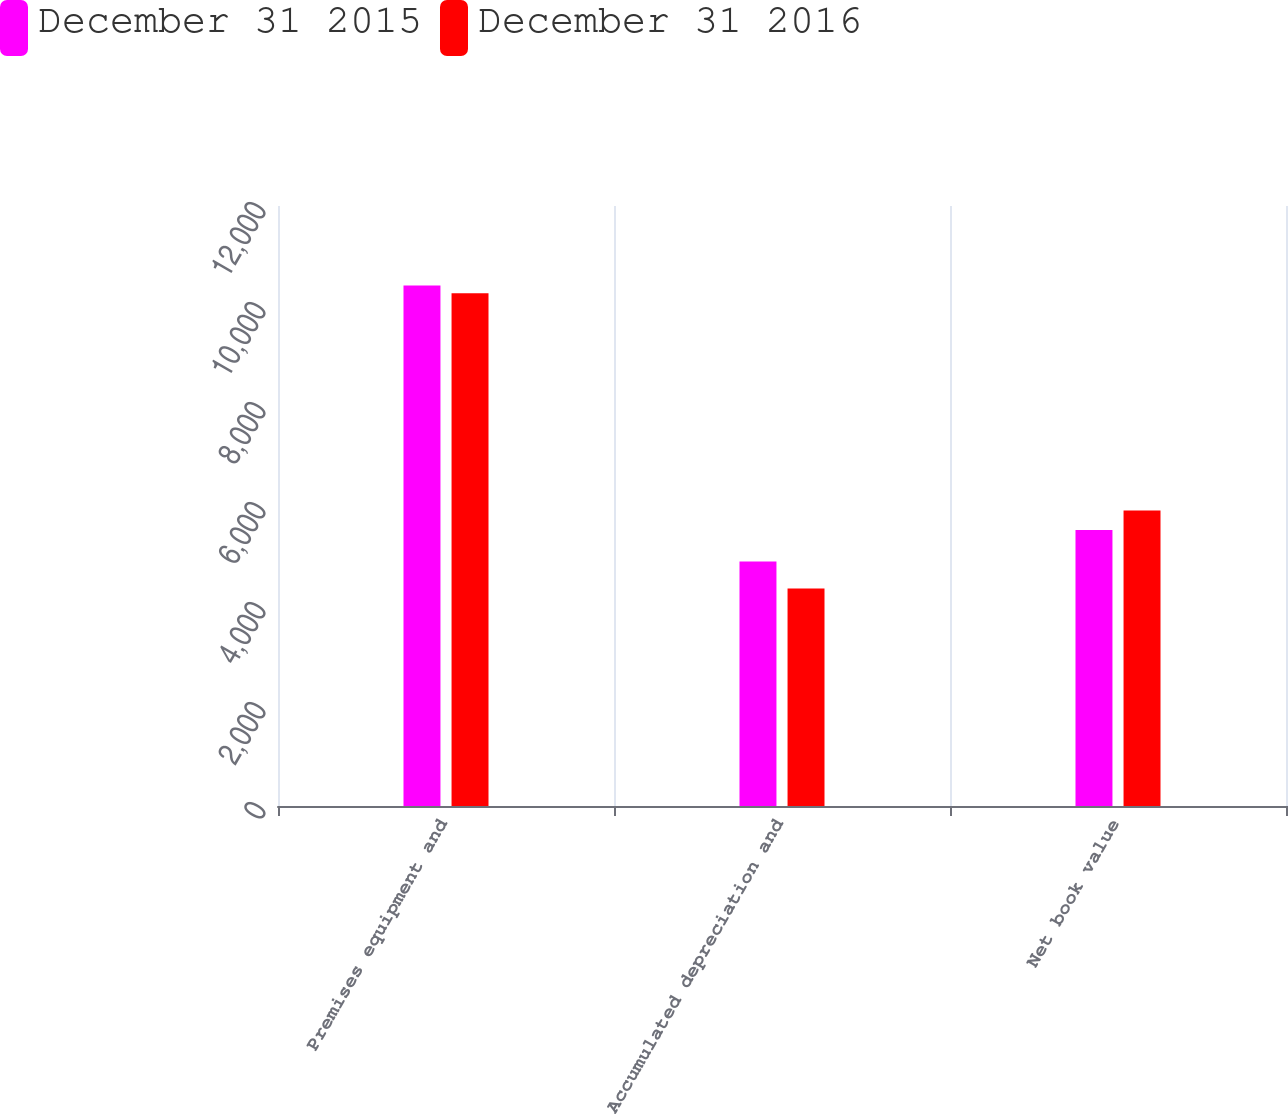Convert chart to OTSL. <chart><loc_0><loc_0><loc_500><loc_500><stacked_bar_chart><ecel><fcel>Premises equipment and<fcel>Accumulated depreciation and<fcel>Net book value<nl><fcel>December 31 2015<fcel>10410<fcel>4888<fcel>5522<nl><fcel>December 31 2016<fcel>10257<fcel>4349<fcel>5908<nl></chart> 